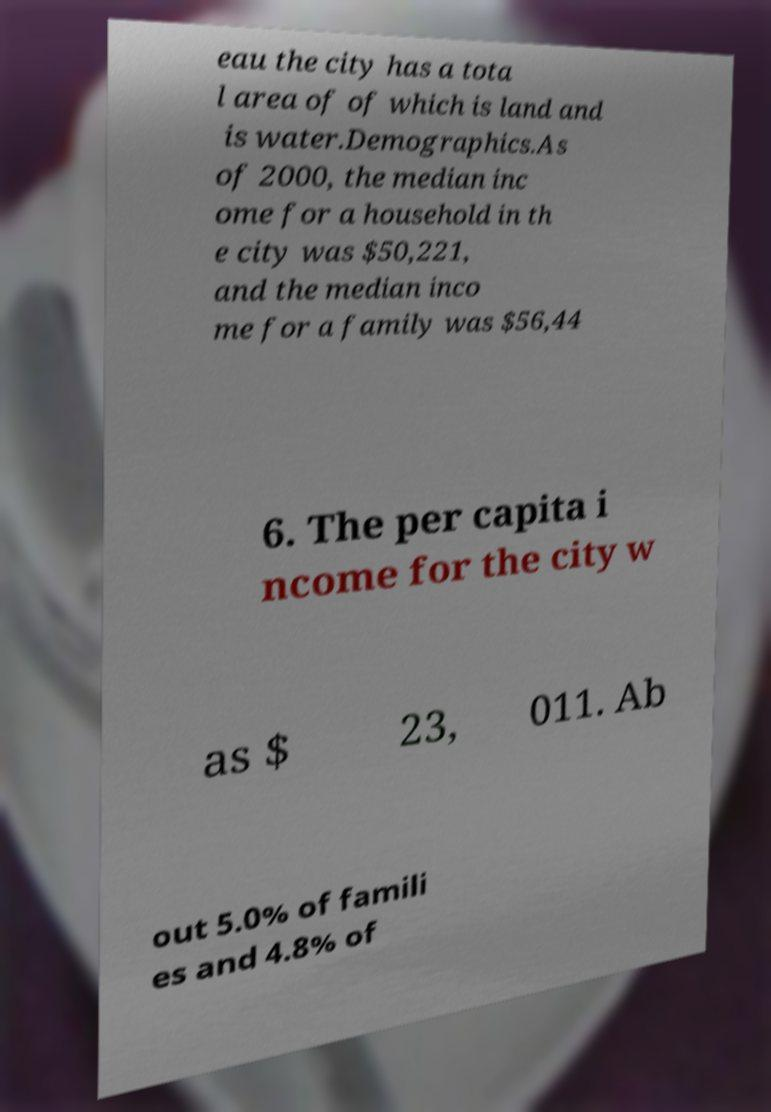Could you extract and type out the text from this image? eau the city has a tota l area of of which is land and is water.Demographics.As of 2000, the median inc ome for a household in th e city was $50,221, and the median inco me for a family was $56,44 6. The per capita i ncome for the city w as $ 23, 011. Ab out 5.0% of famili es and 4.8% of 